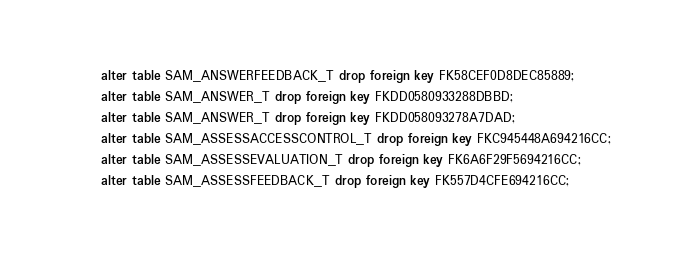Convert code to text. <code><loc_0><loc_0><loc_500><loc_500><_SQL_>alter table SAM_ANSWERFEEDBACK_T drop foreign key FK58CEF0D8DEC85889;
alter table SAM_ANSWER_T drop foreign key FKDD0580933288DBBD;
alter table SAM_ANSWER_T drop foreign key FKDD058093278A7DAD;
alter table SAM_ASSESSACCESSCONTROL_T drop foreign key FKC945448A694216CC;
alter table SAM_ASSESSEVALUATION_T drop foreign key FK6A6F29F5694216CC;
alter table SAM_ASSESSFEEDBACK_T drop foreign key FK557D4CFE694216CC;</code> 